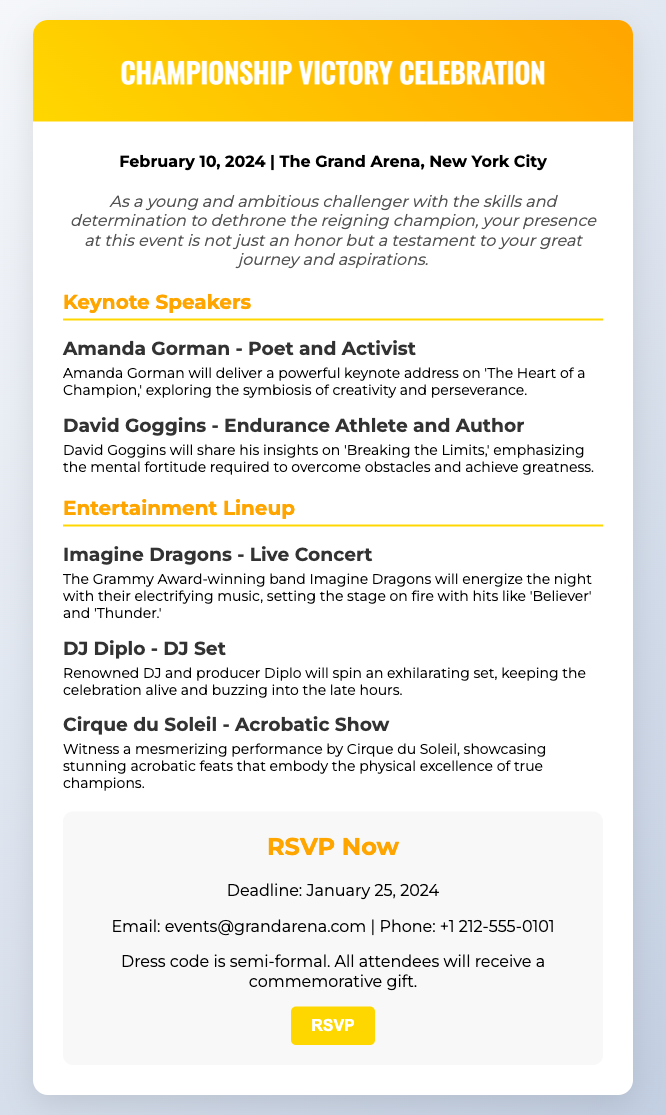What is the date of the event? The date of the event is mentioned in the document, which states it will take place on February 10, 2024.
Answer: February 10, 2024 Where is the event being held? The document specifies that the event will be held at The Grand Arena, New York City.
Answer: The Grand Arena, New York City Who is one of the keynote speakers? The document lists Amanda Gorman and David Goggins as keynote speakers, so either of their names would suffice.
Answer: Amanda Gorman What is the deadline for RSVP? The deadline for RSVP is mentioned clearly in the document, stating it is January 25, 2024.
Answer: January 25, 2024 What type of entertainment is Cirque du Soleil providing? The document indicates that Cirque du Soleil will showcase an acrobatic show at the event.
Answer: Acrobatic Show How will guests be dressed for the occasion? The RSVP card mentions a dress code that is semi-formal for all attendees.
Answer: Semi-formal What is one of the performances by Imagine Dragons? The document highlights that Imagine Dragons will perform hits like 'Believer' and 'Thunder.'
Answer: Believer What is the email for RSVP contact? The document includes the email address provided for RSVP inquiries as events@grandarena.com.
Answer: events@grandarena.com Who is scheduled to DJ during the event? The document lists DJ Diplo as the DJ for the event.
Answer: DJ Diplo 